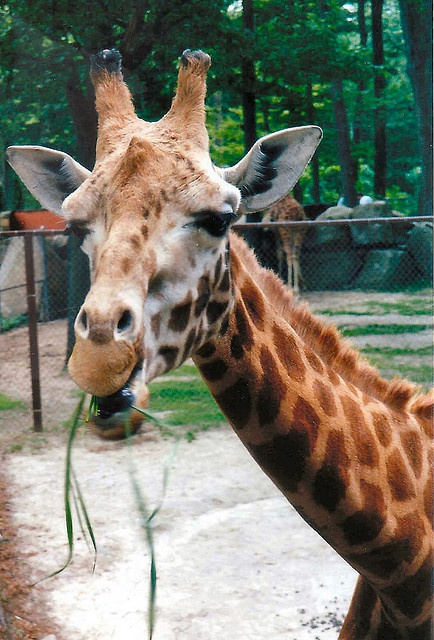Describe the objects in this image and their specific colors. I can see giraffe in black, tan, gray, and maroon tones and giraffe in black and gray tones in this image. 